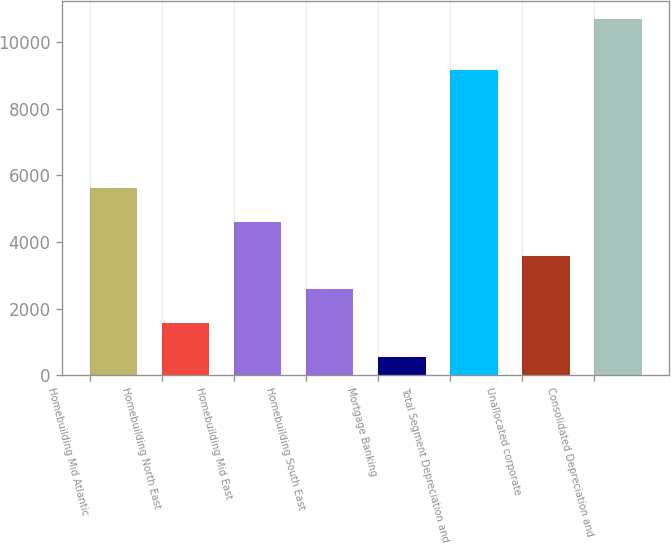Convert chart. <chart><loc_0><loc_0><loc_500><loc_500><bar_chart><fcel>Homebuilding Mid Atlantic<fcel>Homebuilding North East<fcel>Homebuilding Mid East<fcel>Homebuilding South East<fcel>Mortgage Banking<fcel>Total Segment Depreciation and<fcel>Unallocated corporate<fcel>Consolidated Depreciation and<nl><fcel>5621.5<fcel>1566.7<fcel>4607.8<fcel>2580.4<fcel>553<fcel>9164<fcel>3594.1<fcel>10690<nl></chart> 